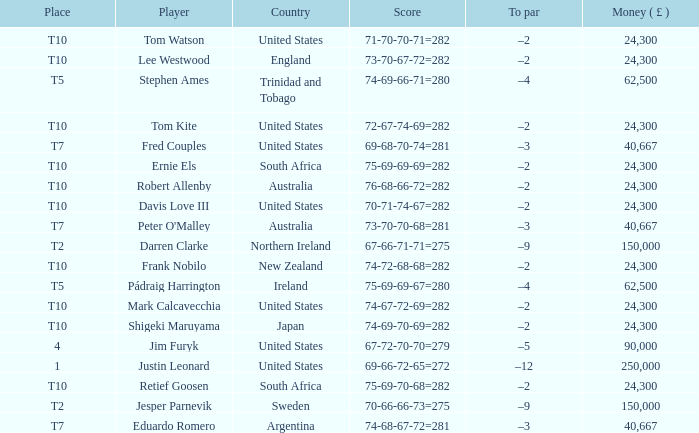How much money has been won by Stephen Ames? 62500.0. 